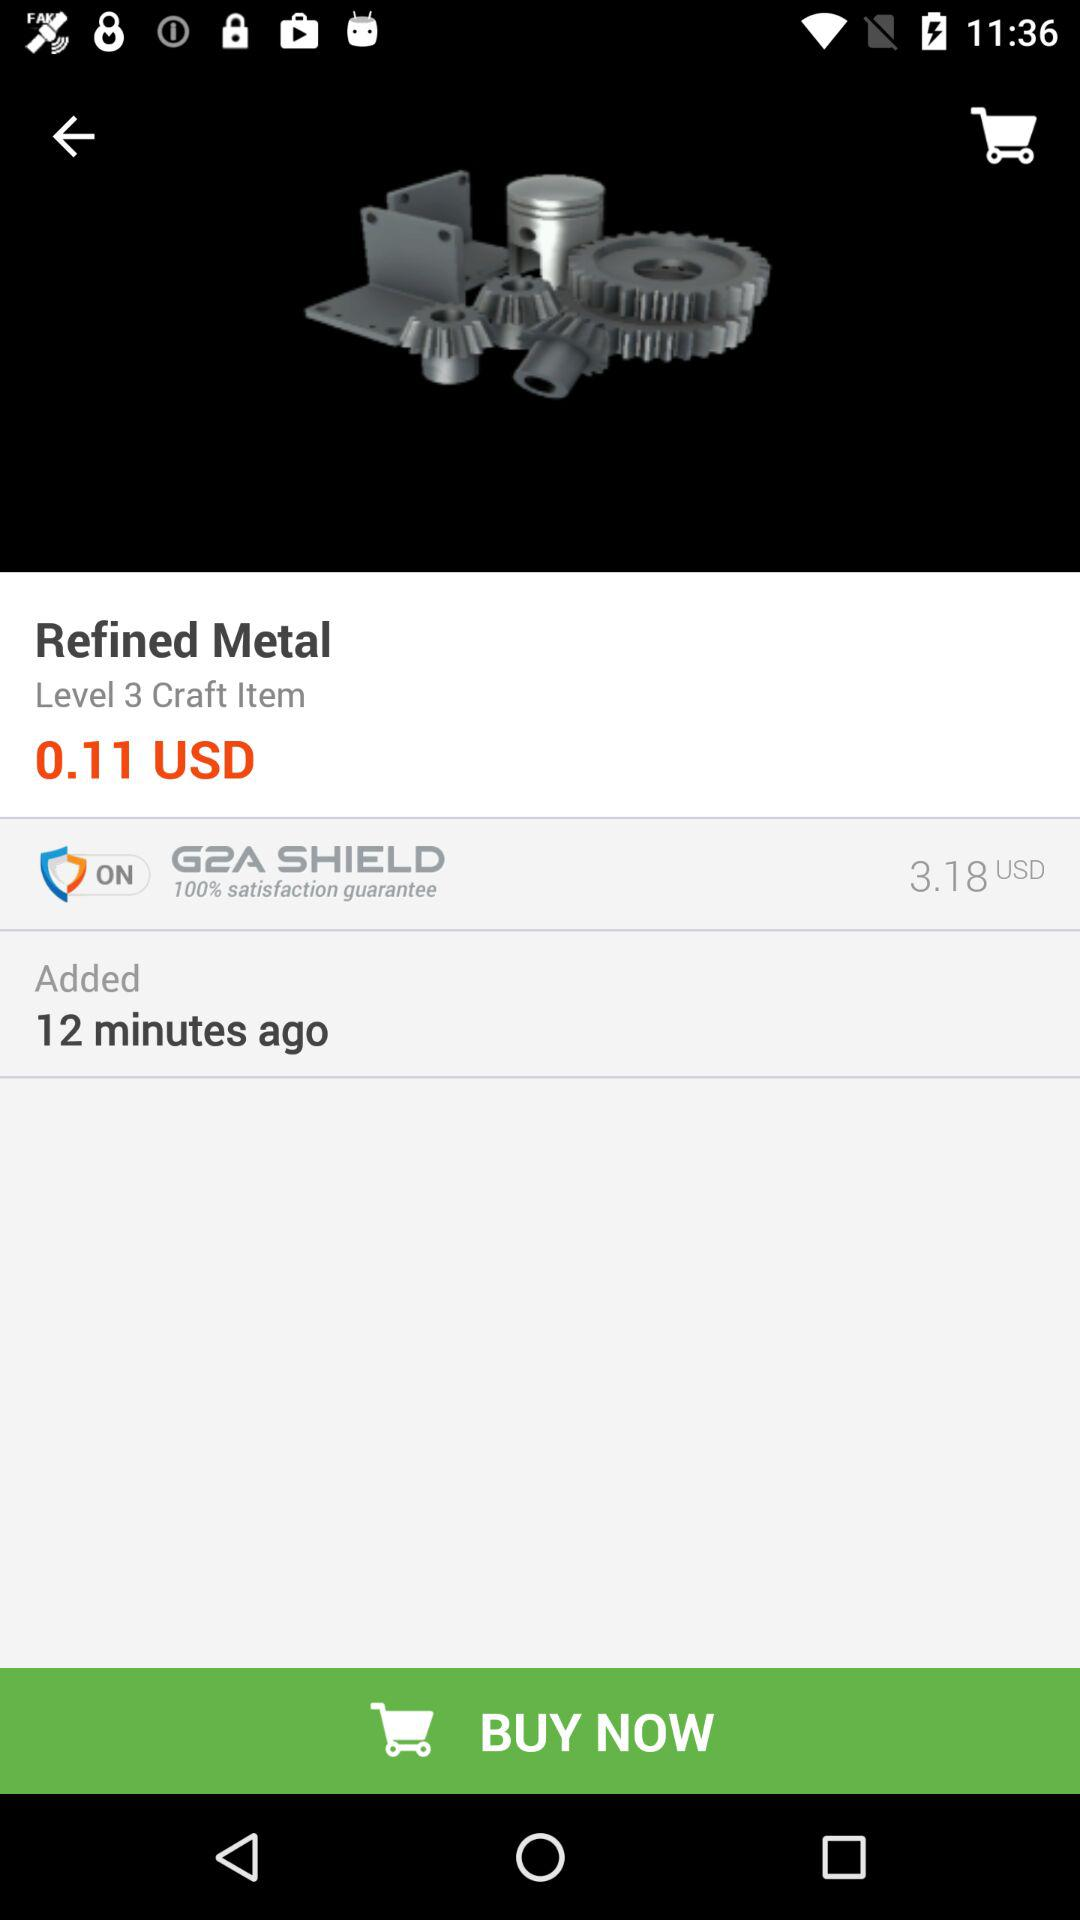What is the time duration?
When the provided information is insufficient, respond with <no answer>. <no answer> 